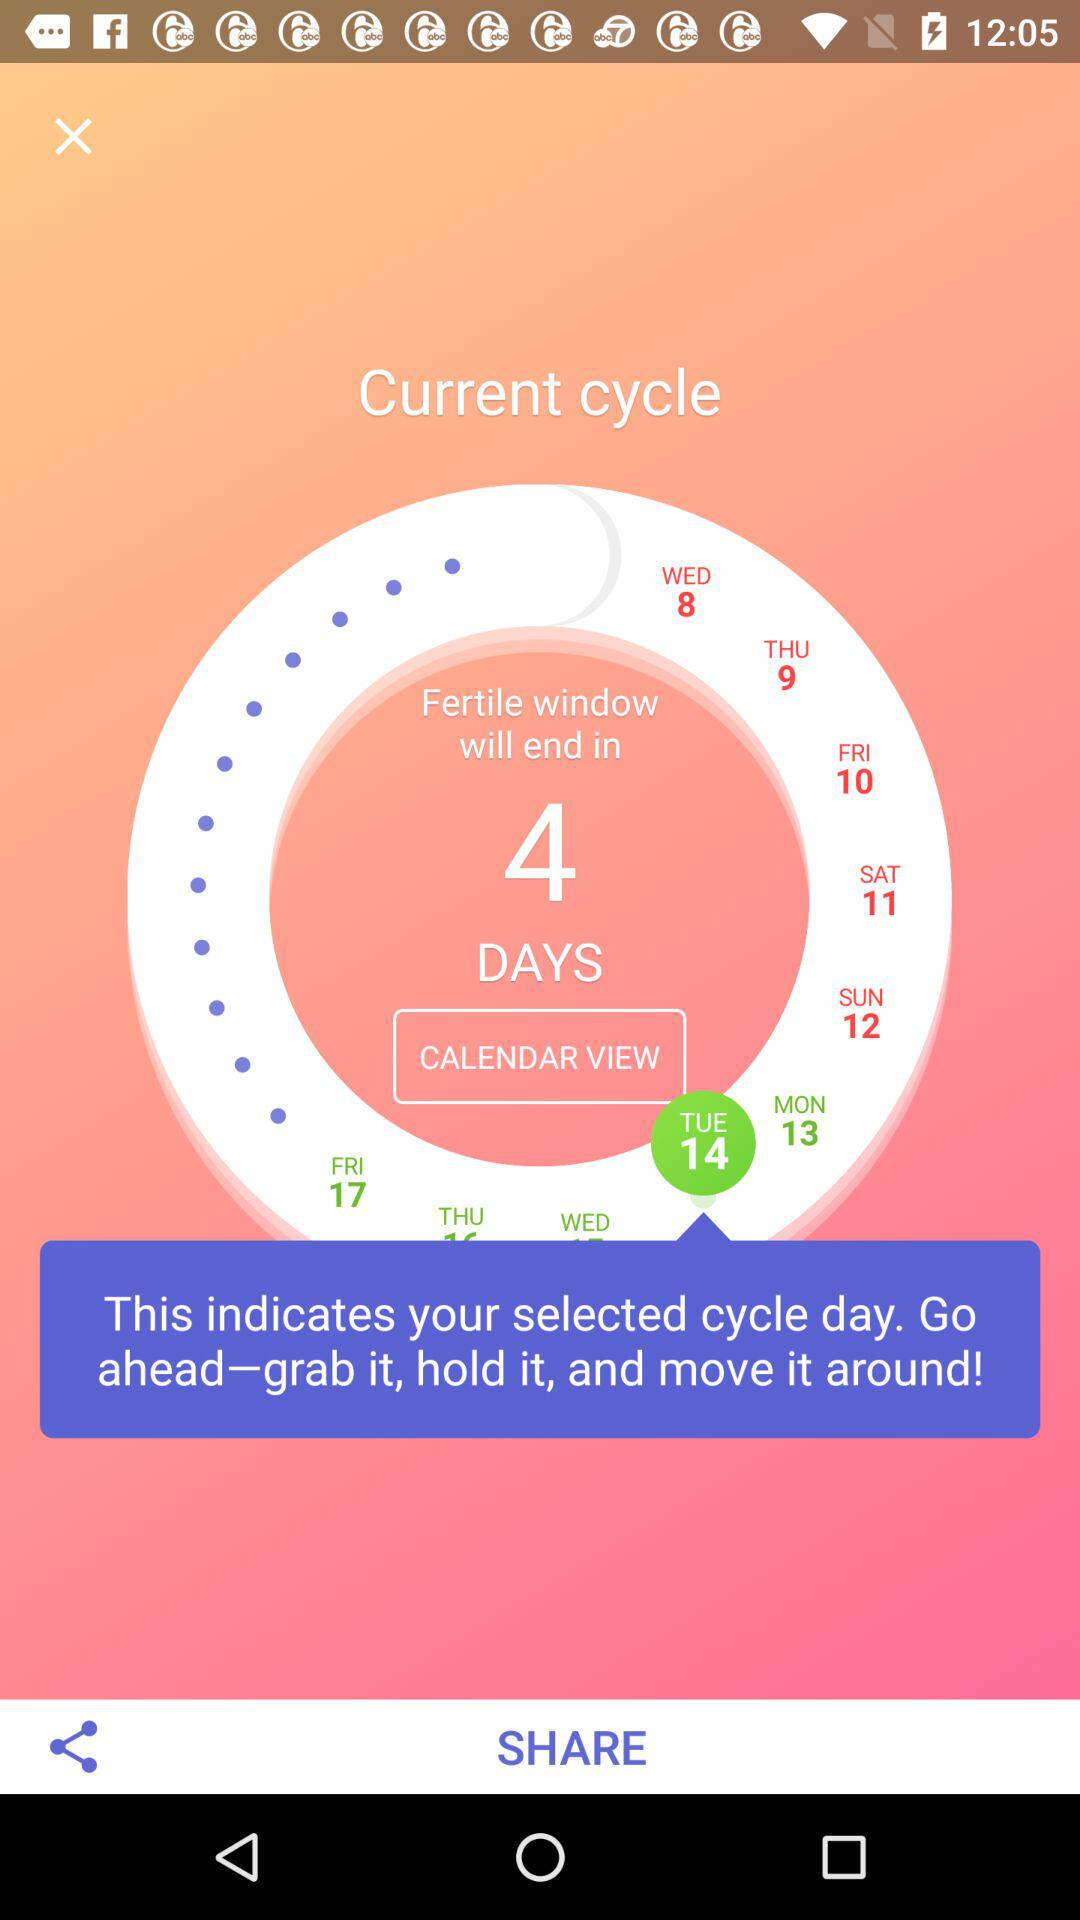How many days are left in the fertile window?
Answer the question using a single word or phrase. 4 